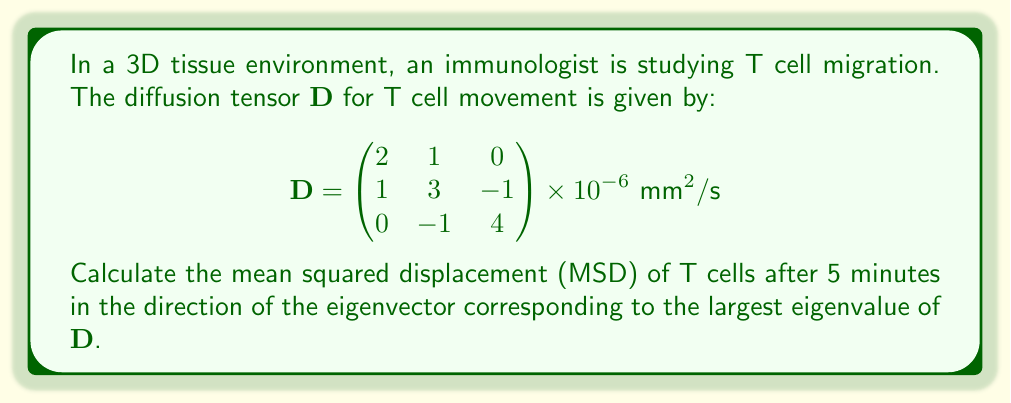Can you solve this math problem? To solve this problem, we'll follow these steps:

1) First, we need to find the eigenvalues of the diffusion tensor $\mathbf{D}$. The characteristic equation is:

   $$\det(\mathbf{D} - \lambda \mathbf{I}) = 0$$

   Solving this equation gives us the eigenvalues:
   $\lambda_1 = 5 \times 10^{-6}$, $\lambda_2 = 3 \times 10^{-6}$, $\lambda_3 = 1 \times 10^{-6}$

2) The largest eigenvalue is $\lambda_1 = 5 \times 10^{-6} \text{ mm}^2/\text{s}$

3) Now we need to find the corresponding eigenvector $\mathbf{v}_1$. We can do this by solving:

   $$(\mathbf{D} - \lambda_1 \mathbf{I})\mathbf{v}_1 = \mathbf{0}$$

   This gives us the eigenvector: $\mathbf{v}_1 = (1, 2, 1)^T$ (normalized)

4) The mean squared displacement (MSD) in the direction of $\mathbf{v}_1$ after time $t$ is given by:

   $$\text{MSD} = 2\lambda_1 t$$

5) We're given $t = 5 \text{ minutes} = 300 \text{ seconds}$

6) Plugging in the values:

   $$\text{MSD} = 2 \times (5 \times 10^{-6} \text{ mm}^2/\text{s}) \times 300 \text{ s}$$
   $$\text{MSD} = 3 \times 10^{-3} \text{ mm}^2$$

Therefore, the mean squared displacement of T cells after 5 minutes in the direction of maximum diffusion is $3 \times 10^{-3} \text{ mm}^2$.
Answer: $3 \times 10^{-3} \text{ mm}^2$ 